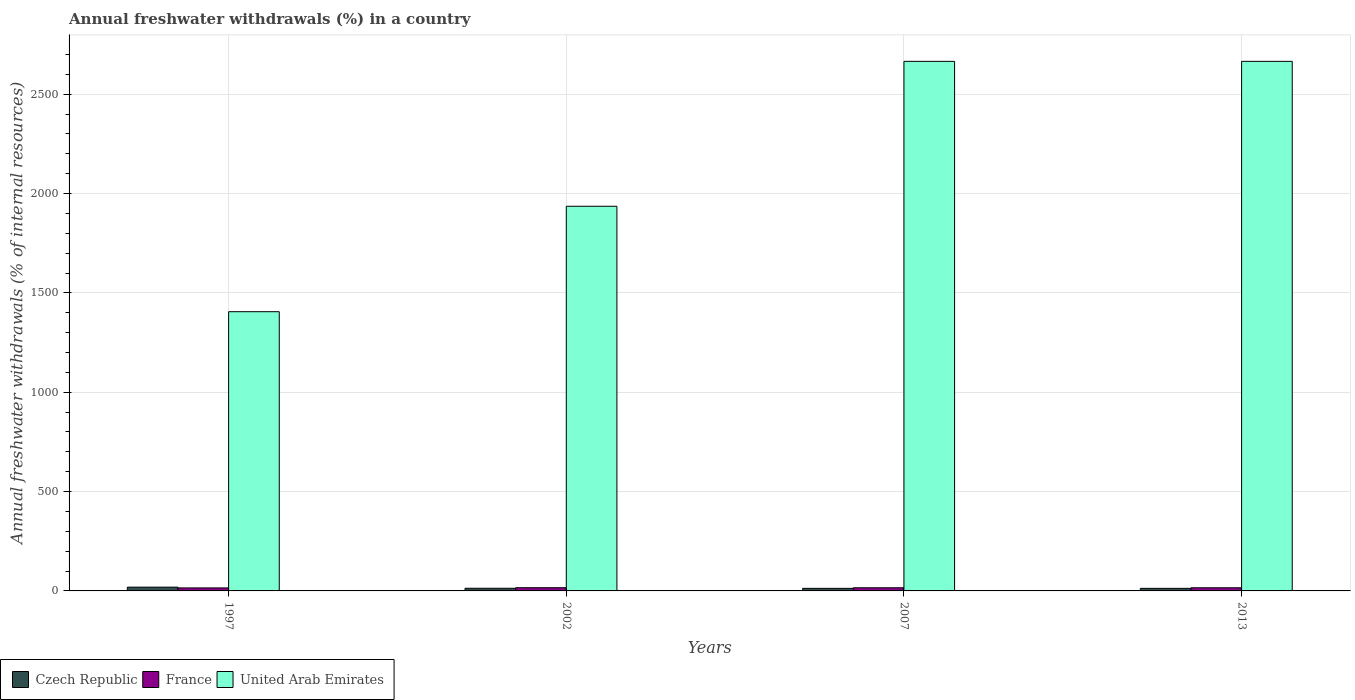How many different coloured bars are there?
Offer a terse response. 3. Are the number of bars per tick equal to the number of legend labels?
Your response must be concise. Yes. Are the number of bars on each tick of the X-axis equal?
Offer a very short reply. Yes. How many bars are there on the 2nd tick from the left?
Give a very brief answer. 3. How many bars are there on the 2nd tick from the right?
Provide a short and direct response. 3. In how many cases, is the number of bars for a given year not equal to the number of legend labels?
Provide a succinct answer. 0. What is the percentage of annual freshwater withdrawals in France in 2007?
Make the answer very short. 15.81. Across all years, what is the maximum percentage of annual freshwater withdrawals in Czech Republic?
Provide a succinct answer. 18.96. Across all years, what is the minimum percentage of annual freshwater withdrawals in France?
Offer a terse response. 15.17. In which year was the percentage of annual freshwater withdrawals in France maximum?
Keep it short and to the point. 2002. In which year was the percentage of annual freshwater withdrawals in France minimum?
Give a very brief answer. 1997. What is the total percentage of annual freshwater withdrawals in France in the graph?
Your answer should be compact. 62.98. What is the difference between the percentage of annual freshwater withdrawals in Czech Republic in 2002 and that in 2013?
Offer a terse response. 0.4. What is the difference between the percentage of annual freshwater withdrawals in United Arab Emirates in 1997 and the percentage of annual freshwater withdrawals in Czech Republic in 2013?
Offer a very short reply. 1392.41. What is the average percentage of annual freshwater withdrawals in France per year?
Give a very brief answer. 15.75. In the year 2007, what is the difference between the percentage of annual freshwater withdrawals in United Arab Emirates and percentage of annual freshwater withdrawals in France?
Make the answer very short. 2649.52. What is the ratio of the percentage of annual freshwater withdrawals in France in 2002 to that in 2013?
Make the answer very short. 1.02. Is the percentage of annual freshwater withdrawals in Czech Republic in 1997 less than that in 2013?
Provide a succinct answer. No. What is the difference between the highest and the second highest percentage of annual freshwater withdrawals in United Arab Emirates?
Your answer should be compact. 0. What is the difference between the highest and the lowest percentage of annual freshwater withdrawals in Czech Republic?
Provide a short and direct response. 6.04. In how many years, is the percentage of annual freshwater withdrawals in Czech Republic greater than the average percentage of annual freshwater withdrawals in Czech Republic taken over all years?
Your response must be concise. 1. Is the sum of the percentage of annual freshwater withdrawals in United Arab Emirates in 1997 and 2002 greater than the maximum percentage of annual freshwater withdrawals in France across all years?
Your answer should be very brief. Yes. What does the 1st bar from the left in 2002 represents?
Ensure brevity in your answer.  Czech Republic. What does the 3rd bar from the right in 2013 represents?
Offer a very short reply. Czech Republic. Is it the case that in every year, the sum of the percentage of annual freshwater withdrawals in Czech Republic and percentage of annual freshwater withdrawals in United Arab Emirates is greater than the percentage of annual freshwater withdrawals in France?
Your answer should be very brief. Yes. Are all the bars in the graph horizontal?
Provide a succinct answer. No. How many years are there in the graph?
Your response must be concise. 4. Where does the legend appear in the graph?
Your answer should be very brief. Bottom left. How are the legend labels stacked?
Offer a terse response. Horizontal. What is the title of the graph?
Ensure brevity in your answer.  Annual freshwater withdrawals (%) in a country. Does "Benin" appear as one of the legend labels in the graph?
Give a very brief answer. No. What is the label or title of the Y-axis?
Provide a short and direct response. Annual freshwater withdrawals (% of internal resources). What is the Annual freshwater withdrawals (% of internal resources) of Czech Republic in 1997?
Offer a terse response. 18.96. What is the Annual freshwater withdrawals (% of internal resources) in France in 1997?
Ensure brevity in your answer.  15.17. What is the Annual freshwater withdrawals (% of internal resources) of United Arab Emirates in 1997?
Keep it short and to the point. 1405.33. What is the Annual freshwater withdrawals (% of internal resources) in Czech Republic in 2002?
Your response must be concise. 13.32. What is the Annual freshwater withdrawals (% of internal resources) in France in 2002?
Your response must be concise. 16.19. What is the Annual freshwater withdrawals (% of internal resources) of United Arab Emirates in 2002?
Provide a succinct answer. 1936. What is the Annual freshwater withdrawals (% of internal resources) in Czech Republic in 2007?
Offer a terse response. 12.92. What is the Annual freshwater withdrawals (% of internal resources) of France in 2007?
Give a very brief answer. 15.81. What is the Annual freshwater withdrawals (% of internal resources) of United Arab Emirates in 2007?
Offer a terse response. 2665.33. What is the Annual freshwater withdrawals (% of internal resources) in Czech Republic in 2013?
Your answer should be very brief. 12.92. What is the Annual freshwater withdrawals (% of internal resources) in France in 2013?
Your response must be concise. 15.81. What is the Annual freshwater withdrawals (% of internal resources) in United Arab Emirates in 2013?
Provide a succinct answer. 2665.33. Across all years, what is the maximum Annual freshwater withdrawals (% of internal resources) of Czech Republic?
Offer a terse response. 18.96. Across all years, what is the maximum Annual freshwater withdrawals (% of internal resources) of France?
Ensure brevity in your answer.  16.19. Across all years, what is the maximum Annual freshwater withdrawals (% of internal resources) of United Arab Emirates?
Keep it short and to the point. 2665.33. Across all years, what is the minimum Annual freshwater withdrawals (% of internal resources) in Czech Republic?
Keep it short and to the point. 12.92. Across all years, what is the minimum Annual freshwater withdrawals (% of internal resources) of France?
Your response must be concise. 15.17. Across all years, what is the minimum Annual freshwater withdrawals (% of internal resources) in United Arab Emirates?
Provide a succinct answer. 1405.33. What is the total Annual freshwater withdrawals (% of internal resources) in Czech Republic in the graph?
Ensure brevity in your answer.  58.12. What is the total Annual freshwater withdrawals (% of internal resources) in France in the graph?
Ensure brevity in your answer.  62.98. What is the total Annual freshwater withdrawals (% of internal resources) of United Arab Emirates in the graph?
Ensure brevity in your answer.  8672. What is the difference between the Annual freshwater withdrawals (% of internal resources) in Czech Republic in 1997 and that in 2002?
Ensure brevity in your answer.  5.63. What is the difference between the Annual freshwater withdrawals (% of internal resources) of France in 1997 and that in 2002?
Provide a short and direct response. -1.02. What is the difference between the Annual freshwater withdrawals (% of internal resources) in United Arab Emirates in 1997 and that in 2002?
Make the answer very short. -530.67. What is the difference between the Annual freshwater withdrawals (% of internal resources) of Czech Republic in 1997 and that in 2007?
Your answer should be compact. 6.04. What is the difference between the Annual freshwater withdrawals (% of internal resources) in France in 1997 and that in 2007?
Provide a short and direct response. -0.64. What is the difference between the Annual freshwater withdrawals (% of internal resources) in United Arab Emirates in 1997 and that in 2007?
Provide a succinct answer. -1260. What is the difference between the Annual freshwater withdrawals (% of internal resources) of Czech Republic in 1997 and that in 2013?
Provide a short and direct response. 6.04. What is the difference between the Annual freshwater withdrawals (% of internal resources) in France in 1997 and that in 2013?
Keep it short and to the point. -0.64. What is the difference between the Annual freshwater withdrawals (% of internal resources) in United Arab Emirates in 1997 and that in 2013?
Keep it short and to the point. -1260. What is the difference between the Annual freshwater withdrawals (% of internal resources) in Czech Republic in 2002 and that in 2007?
Give a very brief answer. 0.4. What is the difference between the Annual freshwater withdrawals (% of internal resources) in France in 2002 and that in 2007?
Keep it short and to the point. 0.38. What is the difference between the Annual freshwater withdrawals (% of internal resources) in United Arab Emirates in 2002 and that in 2007?
Your answer should be very brief. -729.33. What is the difference between the Annual freshwater withdrawals (% of internal resources) in Czech Republic in 2002 and that in 2013?
Ensure brevity in your answer.  0.4. What is the difference between the Annual freshwater withdrawals (% of internal resources) of France in 2002 and that in 2013?
Ensure brevity in your answer.  0.38. What is the difference between the Annual freshwater withdrawals (% of internal resources) in United Arab Emirates in 2002 and that in 2013?
Offer a terse response. -729.33. What is the difference between the Annual freshwater withdrawals (% of internal resources) of Czech Republic in 2007 and that in 2013?
Your response must be concise. 0. What is the difference between the Annual freshwater withdrawals (% of internal resources) in United Arab Emirates in 2007 and that in 2013?
Offer a very short reply. 0. What is the difference between the Annual freshwater withdrawals (% of internal resources) in Czech Republic in 1997 and the Annual freshwater withdrawals (% of internal resources) in France in 2002?
Your answer should be compact. 2.77. What is the difference between the Annual freshwater withdrawals (% of internal resources) in Czech Republic in 1997 and the Annual freshwater withdrawals (% of internal resources) in United Arab Emirates in 2002?
Your response must be concise. -1917.04. What is the difference between the Annual freshwater withdrawals (% of internal resources) in France in 1997 and the Annual freshwater withdrawals (% of internal resources) in United Arab Emirates in 2002?
Offer a very short reply. -1920.83. What is the difference between the Annual freshwater withdrawals (% of internal resources) of Czech Republic in 1997 and the Annual freshwater withdrawals (% of internal resources) of France in 2007?
Provide a short and direct response. 3.15. What is the difference between the Annual freshwater withdrawals (% of internal resources) in Czech Republic in 1997 and the Annual freshwater withdrawals (% of internal resources) in United Arab Emirates in 2007?
Provide a short and direct response. -2646.38. What is the difference between the Annual freshwater withdrawals (% of internal resources) of France in 1997 and the Annual freshwater withdrawals (% of internal resources) of United Arab Emirates in 2007?
Provide a short and direct response. -2650.16. What is the difference between the Annual freshwater withdrawals (% of internal resources) of Czech Republic in 1997 and the Annual freshwater withdrawals (% of internal resources) of France in 2013?
Make the answer very short. 3.15. What is the difference between the Annual freshwater withdrawals (% of internal resources) in Czech Republic in 1997 and the Annual freshwater withdrawals (% of internal resources) in United Arab Emirates in 2013?
Provide a short and direct response. -2646.38. What is the difference between the Annual freshwater withdrawals (% of internal resources) in France in 1997 and the Annual freshwater withdrawals (% of internal resources) in United Arab Emirates in 2013?
Keep it short and to the point. -2650.16. What is the difference between the Annual freshwater withdrawals (% of internal resources) in Czech Republic in 2002 and the Annual freshwater withdrawals (% of internal resources) in France in 2007?
Keep it short and to the point. -2.49. What is the difference between the Annual freshwater withdrawals (% of internal resources) in Czech Republic in 2002 and the Annual freshwater withdrawals (% of internal resources) in United Arab Emirates in 2007?
Your answer should be compact. -2652.01. What is the difference between the Annual freshwater withdrawals (% of internal resources) of France in 2002 and the Annual freshwater withdrawals (% of internal resources) of United Arab Emirates in 2007?
Your answer should be very brief. -2649.14. What is the difference between the Annual freshwater withdrawals (% of internal resources) in Czech Republic in 2002 and the Annual freshwater withdrawals (% of internal resources) in France in 2013?
Provide a succinct answer. -2.49. What is the difference between the Annual freshwater withdrawals (% of internal resources) of Czech Republic in 2002 and the Annual freshwater withdrawals (% of internal resources) of United Arab Emirates in 2013?
Give a very brief answer. -2652.01. What is the difference between the Annual freshwater withdrawals (% of internal resources) of France in 2002 and the Annual freshwater withdrawals (% of internal resources) of United Arab Emirates in 2013?
Offer a very short reply. -2649.14. What is the difference between the Annual freshwater withdrawals (% of internal resources) in Czech Republic in 2007 and the Annual freshwater withdrawals (% of internal resources) in France in 2013?
Your response must be concise. -2.89. What is the difference between the Annual freshwater withdrawals (% of internal resources) in Czech Republic in 2007 and the Annual freshwater withdrawals (% of internal resources) in United Arab Emirates in 2013?
Your response must be concise. -2652.41. What is the difference between the Annual freshwater withdrawals (% of internal resources) in France in 2007 and the Annual freshwater withdrawals (% of internal resources) in United Arab Emirates in 2013?
Ensure brevity in your answer.  -2649.52. What is the average Annual freshwater withdrawals (% of internal resources) in Czech Republic per year?
Offer a terse response. 14.53. What is the average Annual freshwater withdrawals (% of internal resources) in France per year?
Offer a very short reply. 15.74. What is the average Annual freshwater withdrawals (% of internal resources) in United Arab Emirates per year?
Offer a terse response. 2168. In the year 1997, what is the difference between the Annual freshwater withdrawals (% of internal resources) in Czech Republic and Annual freshwater withdrawals (% of internal resources) in France?
Your answer should be compact. 3.79. In the year 1997, what is the difference between the Annual freshwater withdrawals (% of internal resources) in Czech Republic and Annual freshwater withdrawals (% of internal resources) in United Arab Emirates?
Your answer should be compact. -1386.38. In the year 1997, what is the difference between the Annual freshwater withdrawals (% of internal resources) of France and Annual freshwater withdrawals (% of internal resources) of United Arab Emirates?
Give a very brief answer. -1390.16. In the year 2002, what is the difference between the Annual freshwater withdrawals (% of internal resources) in Czech Republic and Annual freshwater withdrawals (% of internal resources) in France?
Your answer should be compact. -2.87. In the year 2002, what is the difference between the Annual freshwater withdrawals (% of internal resources) of Czech Republic and Annual freshwater withdrawals (% of internal resources) of United Arab Emirates?
Offer a terse response. -1922.68. In the year 2002, what is the difference between the Annual freshwater withdrawals (% of internal resources) of France and Annual freshwater withdrawals (% of internal resources) of United Arab Emirates?
Ensure brevity in your answer.  -1919.81. In the year 2007, what is the difference between the Annual freshwater withdrawals (% of internal resources) of Czech Republic and Annual freshwater withdrawals (% of internal resources) of France?
Your response must be concise. -2.89. In the year 2007, what is the difference between the Annual freshwater withdrawals (% of internal resources) of Czech Republic and Annual freshwater withdrawals (% of internal resources) of United Arab Emirates?
Provide a succinct answer. -2652.41. In the year 2007, what is the difference between the Annual freshwater withdrawals (% of internal resources) of France and Annual freshwater withdrawals (% of internal resources) of United Arab Emirates?
Your answer should be very brief. -2649.52. In the year 2013, what is the difference between the Annual freshwater withdrawals (% of internal resources) of Czech Republic and Annual freshwater withdrawals (% of internal resources) of France?
Offer a terse response. -2.89. In the year 2013, what is the difference between the Annual freshwater withdrawals (% of internal resources) in Czech Republic and Annual freshwater withdrawals (% of internal resources) in United Arab Emirates?
Offer a very short reply. -2652.41. In the year 2013, what is the difference between the Annual freshwater withdrawals (% of internal resources) of France and Annual freshwater withdrawals (% of internal resources) of United Arab Emirates?
Make the answer very short. -2649.52. What is the ratio of the Annual freshwater withdrawals (% of internal resources) of Czech Republic in 1997 to that in 2002?
Make the answer very short. 1.42. What is the ratio of the Annual freshwater withdrawals (% of internal resources) in France in 1997 to that in 2002?
Keep it short and to the point. 0.94. What is the ratio of the Annual freshwater withdrawals (% of internal resources) of United Arab Emirates in 1997 to that in 2002?
Your answer should be compact. 0.73. What is the ratio of the Annual freshwater withdrawals (% of internal resources) of Czech Republic in 1997 to that in 2007?
Offer a terse response. 1.47. What is the ratio of the Annual freshwater withdrawals (% of internal resources) in France in 1997 to that in 2007?
Your response must be concise. 0.96. What is the ratio of the Annual freshwater withdrawals (% of internal resources) in United Arab Emirates in 1997 to that in 2007?
Your answer should be compact. 0.53. What is the ratio of the Annual freshwater withdrawals (% of internal resources) in Czech Republic in 1997 to that in 2013?
Give a very brief answer. 1.47. What is the ratio of the Annual freshwater withdrawals (% of internal resources) in France in 1997 to that in 2013?
Offer a very short reply. 0.96. What is the ratio of the Annual freshwater withdrawals (% of internal resources) of United Arab Emirates in 1997 to that in 2013?
Provide a succinct answer. 0.53. What is the ratio of the Annual freshwater withdrawals (% of internal resources) of Czech Republic in 2002 to that in 2007?
Provide a succinct answer. 1.03. What is the ratio of the Annual freshwater withdrawals (% of internal resources) of France in 2002 to that in 2007?
Ensure brevity in your answer.  1.02. What is the ratio of the Annual freshwater withdrawals (% of internal resources) in United Arab Emirates in 2002 to that in 2007?
Offer a terse response. 0.73. What is the ratio of the Annual freshwater withdrawals (% of internal resources) in Czech Republic in 2002 to that in 2013?
Provide a succinct answer. 1.03. What is the ratio of the Annual freshwater withdrawals (% of internal resources) of France in 2002 to that in 2013?
Provide a short and direct response. 1.02. What is the ratio of the Annual freshwater withdrawals (% of internal resources) in United Arab Emirates in 2002 to that in 2013?
Ensure brevity in your answer.  0.73. What is the ratio of the Annual freshwater withdrawals (% of internal resources) of Czech Republic in 2007 to that in 2013?
Ensure brevity in your answer.  1. What is the ratio of the Annual freshwater withdrawals (% of internal resources) of France in 2007 to that in 2013?
Ensure brevity in your answer.  1. What is the difference between the highest and the second highest Annual freshwater withdrawals (% of internal resources) of Czech Republic?
Ensure brevity in your answer.  5.63. What is the difference between the highest and the second highest Annual freshwater withdrawals (% of internal resources) of France?
Keep it short and to the point. 0.38. What is the difference between the highest and the lowest Annual freshwater withdrawals (% of internal resources) in Czech Republic?
Your answer should be very brief. 6.04. What is the difference between the highest and the lowest Annual freshwater withdrawals (% of internal resources) of France?
Keep it short and to the point. 1.02. What is the difference between the highest and the lowest Annual freshwater withdrawals (% of internal resources) in United Arab Emirates?
Make the answer very short. 1260. 